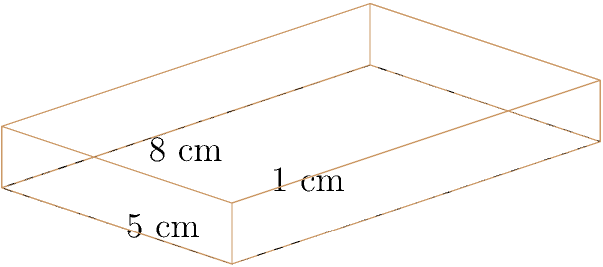You're designing a new rectangular makeup palette for a cosplay photoshoot. The palette measures 8 cm in length, 5 cm in width, and 1 cm in height. What is the total surface area of the palette in square centimeters? To find the total surface area of the rectangular makeup palette, we need to calculate the area of all six faces and sum them up. Let's break it down step-by-step:

1. Top and bottom faces:
   - Area of each = length × width
   - Area = 8 cm × 5 cm = 40 cm²
   - Total area of top and bottom = 2 × 40 cm² = 80 cm²

2. Front and back faces:
   - Area of each = length × height
   - Area = 8 cm × 1 cm = 8 cm²
   - Total area of front and back = 2 × 8 cm² = 16 cm²

3. Left and right faces:
   - Area of each = width × height
   - Area = 5 cm × 1 cm = 5 cm²
   - Total area of left and right = 2 × 5 cm² = 10 cm²

4. Total surface area:
   Sum of all faces = 80 cm² + 16 cm² + 10 cm² = 106 cm²

Therefore, the total surface area of the makeup palette is 106 cm².
Answer: 106 cm² 